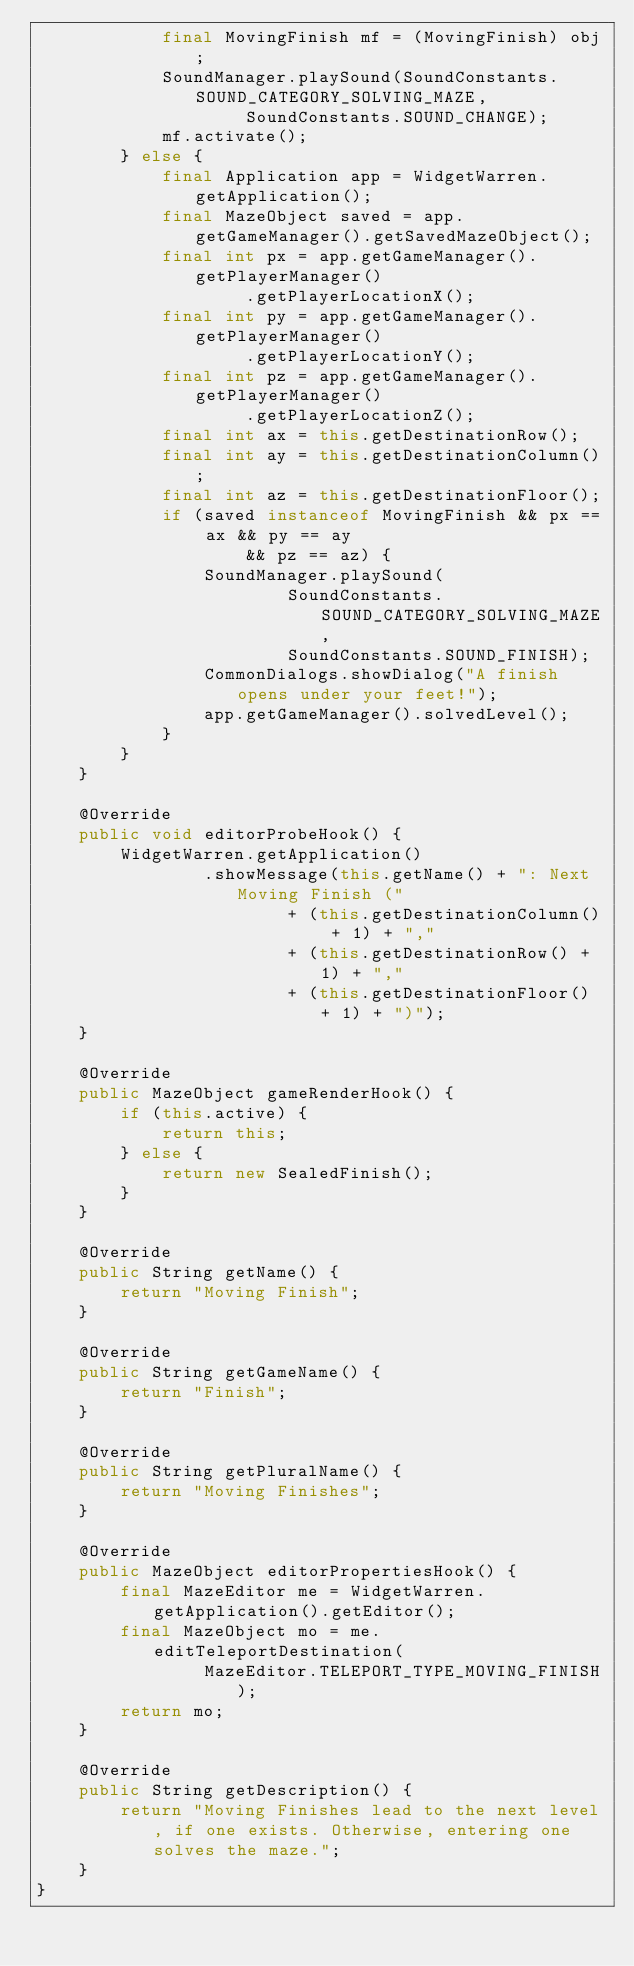Convert code to text. <code><loc_0><loc_0><loc_500><loc_500><_Java_>            final MovingFinish mf = (MovingFinish) obj;
            SoundManager.playSound(SoundConstants.SOUND_CATEGORY_SOLVING_MAZE,
                    SoundConstants.SOUND_CHANGE);
            mf.activate();
        } else {
            final Application app = WidgetWarren.getApplication();
            final MazeObject saved = app.getGameManager().getSavedMazeObject();
            final int px = app.getGameManager().getPlayerManager()
                    .getPlayerLocationX();
            final int py = app.getGameManager().getPlayerManager()
                    .getPlayerLocationY();
            final int pz = app.getGameManager().getPlayerManager()
                    .getPlayerLocationZ();
            final int ax = this.getDestinationRow();
            final int ay = this.getDestinationColumn();
            final int az = this.getDestinationFloor();
            if (saved instanceof MovingFinish && px == ax && py == ay
                    && pz == az) {
                SoundManager.playSound(
                        SoundConstants.SOUND_CATEGORY_SOLVING_MAZE,
                        SoundConstants.SOUND_FINISH);
                CommonDialogs.showDialog("A finish opens under your feet!");
                app.getGameManager().solvedLevel();
            }
        }
    }

    @Override
    public void editorProbeHook() {
        WidgetWarren.getApplication()
                .showMessage(this.getName() + ": Next Moving Finish ("
                        + (this.getDestinationColumn() + 1) + ","
                        + (this.getDestinationRow() + 1) + ","
                        + (this.getDestinationFloor() + 1) + ")");
    }

    @Override
    public MazeObject gameRenderHook() {
        if (this.active) {
            return this;
        } else {
            return new SealedFinish();
        }
    }

    @Override
    public String getName() {
        return "Moving Finish";
    }

    @Override
    public String getGameName() {
        return "Finish";
    }

    @Override
    public String getPluralName() {
        return "Moving Finishes";
    }

    @Override
    public MazeObject editorPropertiesHook() {
        final MazeEditor me = WidgetWarren.getApplication().getEditor();
        final MazeObject mo = me.editTeleportDestination(
                MazeEditor.TELEPORT_TYPE_MOVING_FINISH);
        return mo;
    }

    @Override
    public String getDescription() {
        return "Moving Finishes lead to the next level, if one exists. Otherwise, entering one solves the maze.";
    }
}</code> 